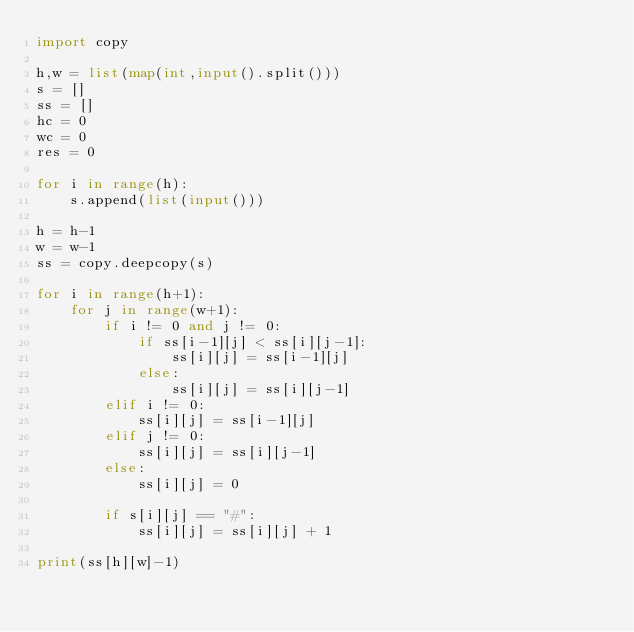Convert code to text. <code><loc_0><loc_0><loc_500><loc_500><_Python_>import copy

h,w = list(map(int,input().split()))
s = []
ss = []
hc = 0
wc = 0
res = 0

for i in range(h):
    s.append(list(input()))

h = h-1
w = w-1
ss = copy.deepcopy(s)

for i in range(h+1):
    for j in range(w+1):
        if i != 0 and j != 0:
            if ss[i-1][j] < ss[i][j-1]:
                ss[i][j] = ss[i-1][j]
            else:
                ss[i][j] = ss[i][j-1]
        elif i != 0:
            ss[i][j] = ss[i-1][j]
        elif j != 0:
            ss[i][j] = ss[i][j-1]
        else:
            ss[i][j] = 0

        if s[i][j] == "#":
            ss[i][j] = ss[i][j] + 1

print(ss[h][w]-1)
</code> 